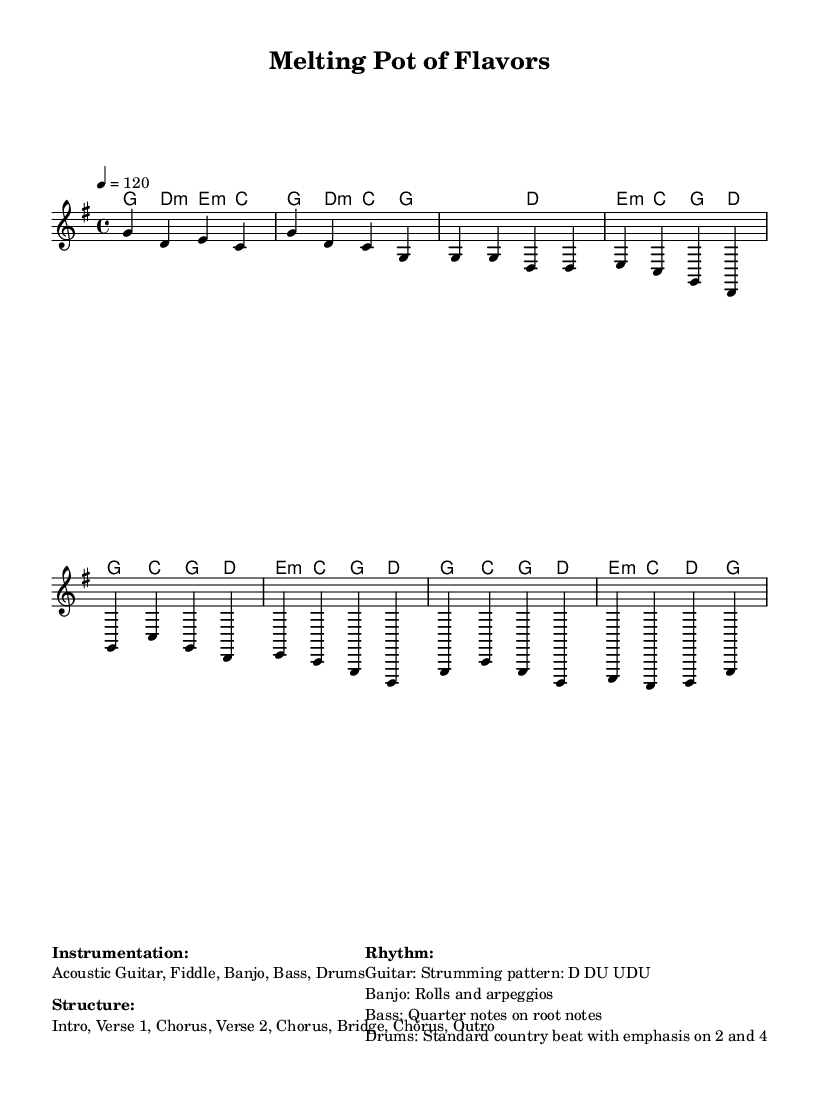What is the key signature of this music? The key signature is G major, which has one sharp (F#). This can be identified by the presence of one sharp in the key signature section at the beginning of the score.
Answer: G major What is the time signature of this music? The time signature is 4/4, which indicates that there are four beats in each measure and the quarter note gets one beat. This is specified in the header of the score under the time signature section.
Answer: 4/4 What is the tempo marking for this piece? The tempo marking is 120 beats per minute, indicated in the tempo directive section where "4 = 120" is specified, meaning one quarter note equals 120 beats.
Answer: 120 How many instruments are listed in the instrumentation? The instrumentation lists five instruments: Acoustic Guitar, Fiddle, Banjo, Bass, and Drums. This is shown in the instrumentation section of the markup.
Answer: Five What is the structure of the piece? The structure is Intro, Verse 1, Chorus, Verse 2, Chorus, Bridge, Chorus, Outro. This layout is detailed in the structure section of the markup.
Answer: Intro, Verse 1, Chorus, Verse 2, Chorus, Bridge, Chorus, Outro Which string instrument is commonly featured in country music shown here? The common string instrument featured is the Banjo. This is highlighted in the instrumentation section of the markup, which lists Banjo as one of the main instruments used in the arrangement.
Answer: Banjo What type of strumming pattern is used for the Guitar? The strumming pattern is Down Up Down Up Down Up. This specific pattern is noted in the rhythm section, providing insight into how the guitar should be played in this piece.
Answer: D DU UDU 